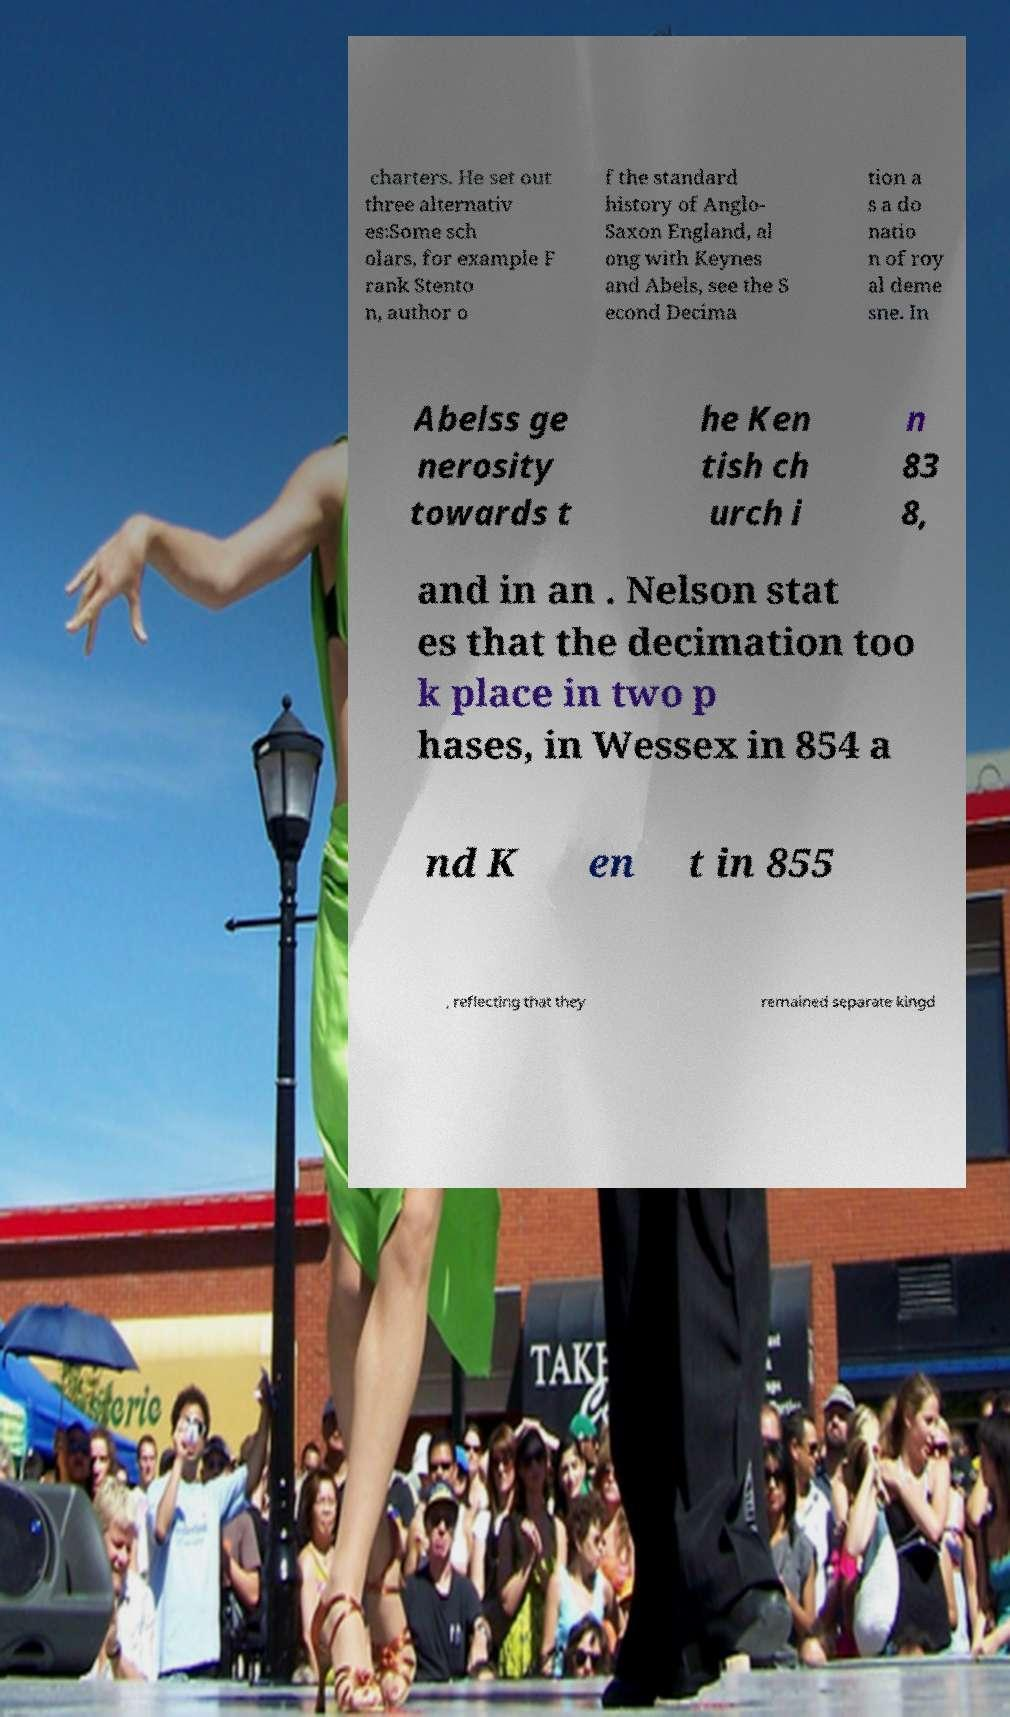Please identify and transcribe the text found in this image. charters. He set out three alternativ es:Some sch olars, for example F rank Stento n, author o f the standard history of Anglo- Saxon England, al ong with Keynes and Abels, see the S econd Decima tion a s a do natio n of roy al deme sne. In Abelss ge nerosity towards t he Ken tish ch urch i n 83 8, and in an . Nelson stat es that the decimation too k place in two p hases, in Wessex in 854 a nd K en t in 855 , reflecting that they remained separate kingd 